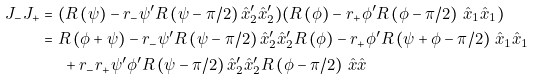<formula> <loc_0><loc_0><loc_500><loc_500>J _ { - } J _ { + } & = ( R \left ( \psi \right ) - r _ { - } \psi ^ { \prime } R \left ( \psi - \pi / 2 \right ) \hat { x } _ { 2 } ^ { \prime } \hat { x } _ { 2 } ^ { \prime } ) ( R \left ( \phi \right ) - r _ { + } \phi ^ { \prime } R \left ( \phi - \pi / 2 \right ) \, \hat { x } _ { 1 } \hat { x } _ { 1 } ) \\ & = R \left ( \phi + \psi \right ) - r _ { - } \psi ^ { \prime } R \left ( \psi - \pi / 2 \right ) \hat { x } _ { 2 } ^ { \prime } \hat { x } _ { 2 } ^ { \prime } R \left ( \phi \right ) - r _ { + } \phi ^ { \prime } R \left ( \psi + \phi - \pi / 2 \right ) \, \hat { x } _ { 1 } \hat { x } _ { 1 } \\ & \ \quad + r _ { - } r _ { + } \psi ^ { \prime } \phi ^ { \prime } R \left ( \psi - \pi / 2 \right ) \hat { x } _ { 2 } ^ { \prime } \hat { x } _ { 2 } ^ { \prime } R \left ( \phi - \pi / 2 \right ) \, \hat { x } \hat { x }</formula> 